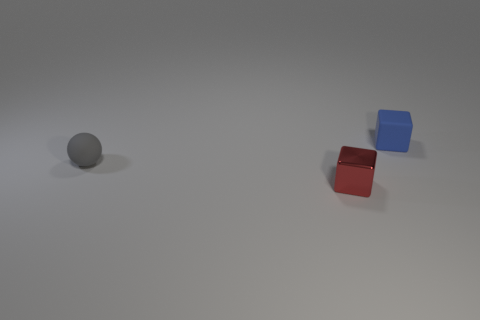Is there anything else that has the same material as the red cube?
Make the answer very short. No. What size is the block behind the tiny gray matte object?
Give a very brief answer. Small. What is the material of the tiny block that is in front of the tiny blue rubber block?
Your answer should be very brief. Metal. What number of blue things are big matte cylinders or tiny matte things?
Provide a short and direct response. 1. Does the ball have the same material as the small object that is in front of the small gray rubber ball?
Keep it short and to the point. No. Are there the same number of small blue cubes that are to the left of the small ball and small blue objects that are to the left of the red object?
Make the answer very short. Yes. Does the red block have the same size as the object that is behind the small matte sphere?
Your answer should be compact. Yes. Is the number of small things that are in front of the blue matte object greater than the number of small red metallic objects?
Offer a very short reply. Yes. What number of other purple matte spheres are the same size as the sphere?
Your answer should be compact. 0. Do the rubber object on the right side of the small metallic cube and the object in front of the gray rubber object have the same size?
Make the answer very short. Yes. 